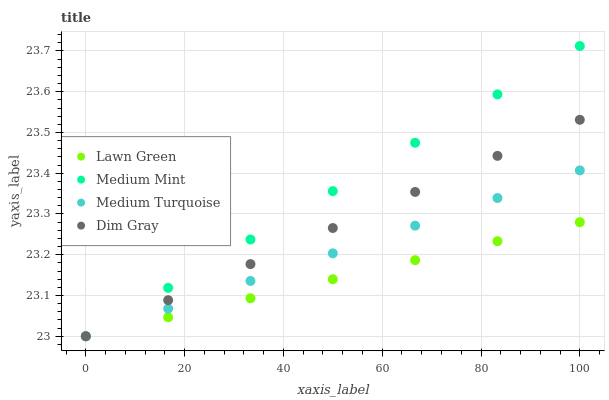Does Lawn Green have the minimum area under the curve?
Answer yes or no. Yes. Does Medium Mint have the maximum area under the curve?
Answer yes or no. Yes. Does Dim Gray have the minimum area under the curve?
Answer yes or no. No. Does Dim Gray have the maximum area under the curve?
Answer yes or no. No. Is Lawn Green the smoothest?
Answer yes or no. Yes. Is Dim Gray the roughest?
Answer yes or no. Yes. Is Dim Gray the smoothest?
Answer yes or no. No. Is Lawn Green the roughest?
Answer yes or no. No. Does Medium Mint have the lowest value?
Answer yes or no. Yes. Does Medium Mint have the highest value?
Answer yes or no. Yes. Does Dim Gray have the highest value?
Answer yes or no. No. Does Dim Gray intersect Medium Turquoise?
Answer yes or no. Yes. Is Dim Gray less than Medium Turquoise?
Answer yes or no. No. Is Dim Gray greater than Medium Turquoise?
Answer yes or no. No. 